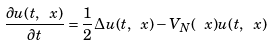Convert formula to latex. <formula><loc_0><loc_0><loc_500><loc_500>\frac { \partial u ( t , \ x ) } { \partial t } = \frac { 1 } { 2 } \Delta u ( t , \ x ) - V _ { N } ( \ x ) u ( t , \ x )</formula> 